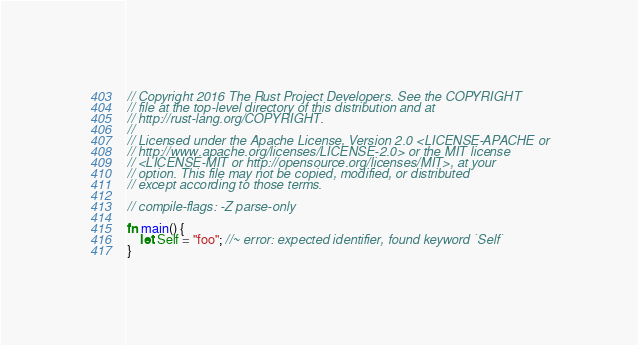<code> <loc_0><loc_0><loc_500><loc_500><_Rust_>// Copyright 2016 The Rust Project Developers. See the COPYRIGHT
// file at the top-level directory of this distribution and at
// http://rust-lang.org/COPYRIGHT.
//
// Licensed under the Apache License, Version 2.0 <LICENSE-APACHE or
// http://www.apache.org/licenses/LICENSE-2.0> or the MIT license
// <LICENSE-MIT or http://opensource.org/licenses/MIT>, at your
// option. This file may not be copied, modified, or distributed
// except according to those terms.

// compile-flags: -Z parse-only

fn main() {
    let Self = "foo"; //~ error: expected identifier, found keyword `Self`
}
</code> 